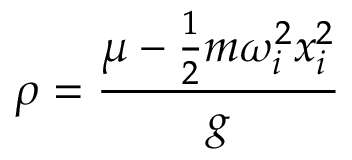<formula> <loc_0><loc_0><loc_500><loc_500>\rho = \frac { \mu - \frac { 1 } { 2 } m \omega _ { i } ^ { 2 } x _ { i } ^ { 2 } } { g }</formula> 